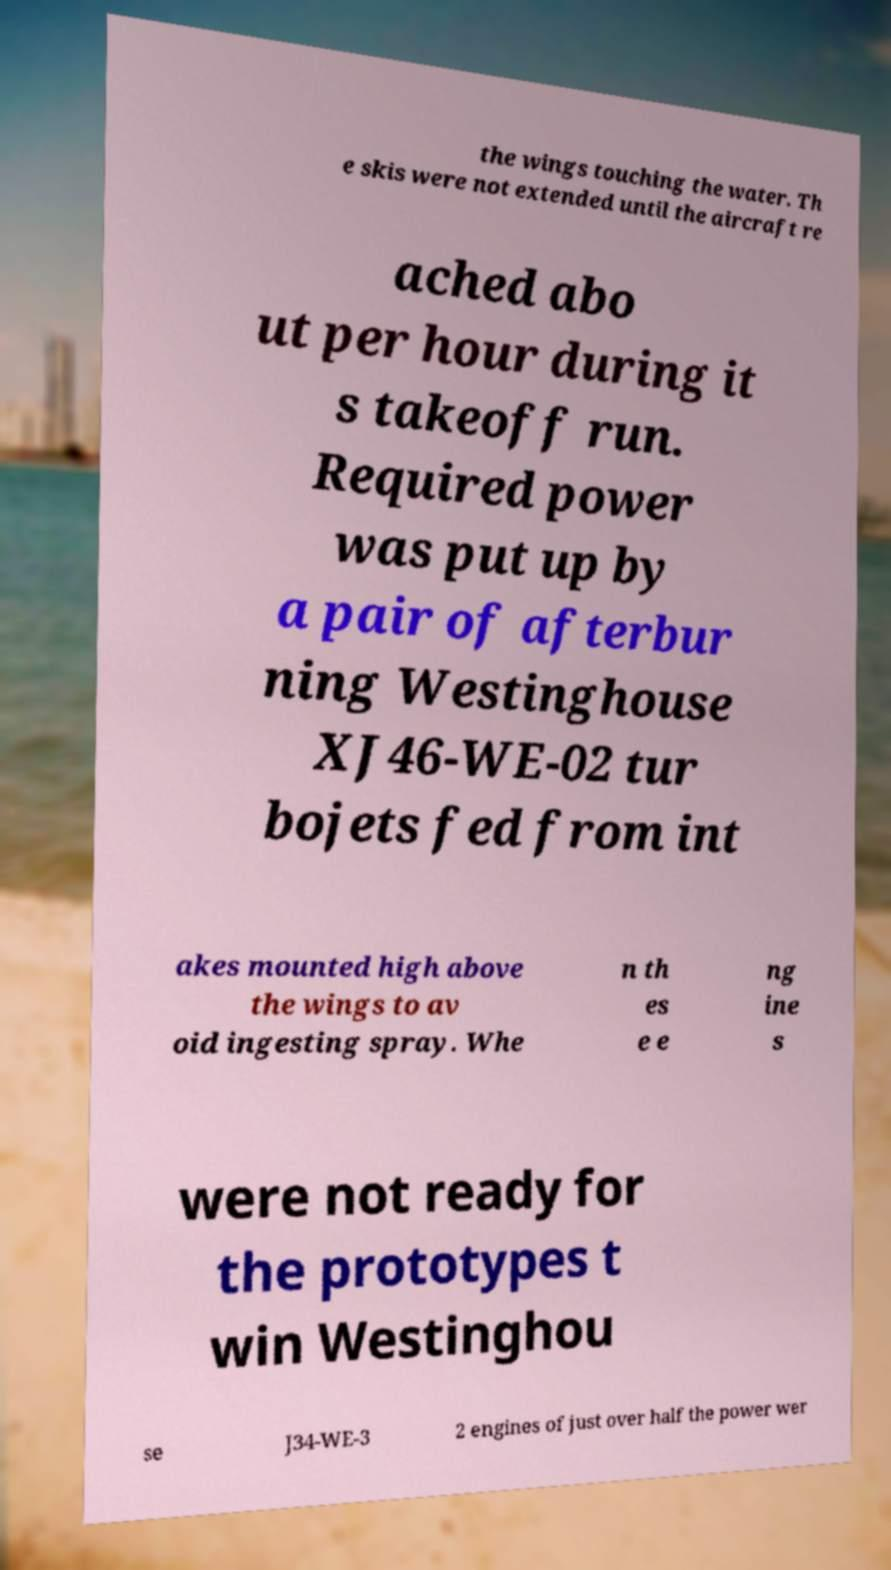Can you read and provide the text displayed in the image?This photo seems to have some interesting text. Can you extract and type it out for me? the wings touching the water. Th e skis were not extended until the aircraft re ached abo ut per hour during it s takeoff run. Required power was put up by a pair of afterbur ning Westinghouse XJ46-WE-02 tur bojets fed from int akes mounted high above the wings to av oid ingesting spray. Whe n th es e e ng ine s were not ready for the prototypes t win Westinghou se J34-WE-3 2 engines of just over half the power wer 